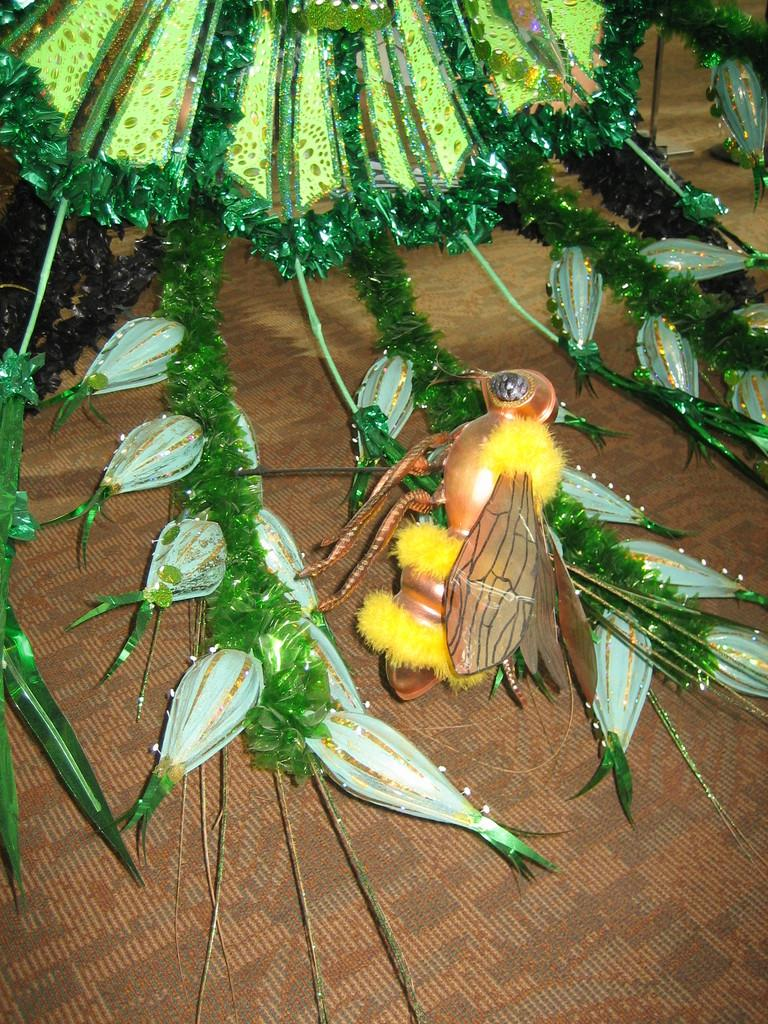What type of decorative item can be seen in the image that resembles an insect? There is a decorative item in the image that resembles an insect. What type of decorative item can be seen in the image that resembles a tree? There is a decorative item in the image that resembles a tree. How many mines can be seen in the image? There are no mines present in the image. What type of grip does the insect have in the image? There is no indication of the insect having a grip in the image, as it is a decorative item and not a living creature. 